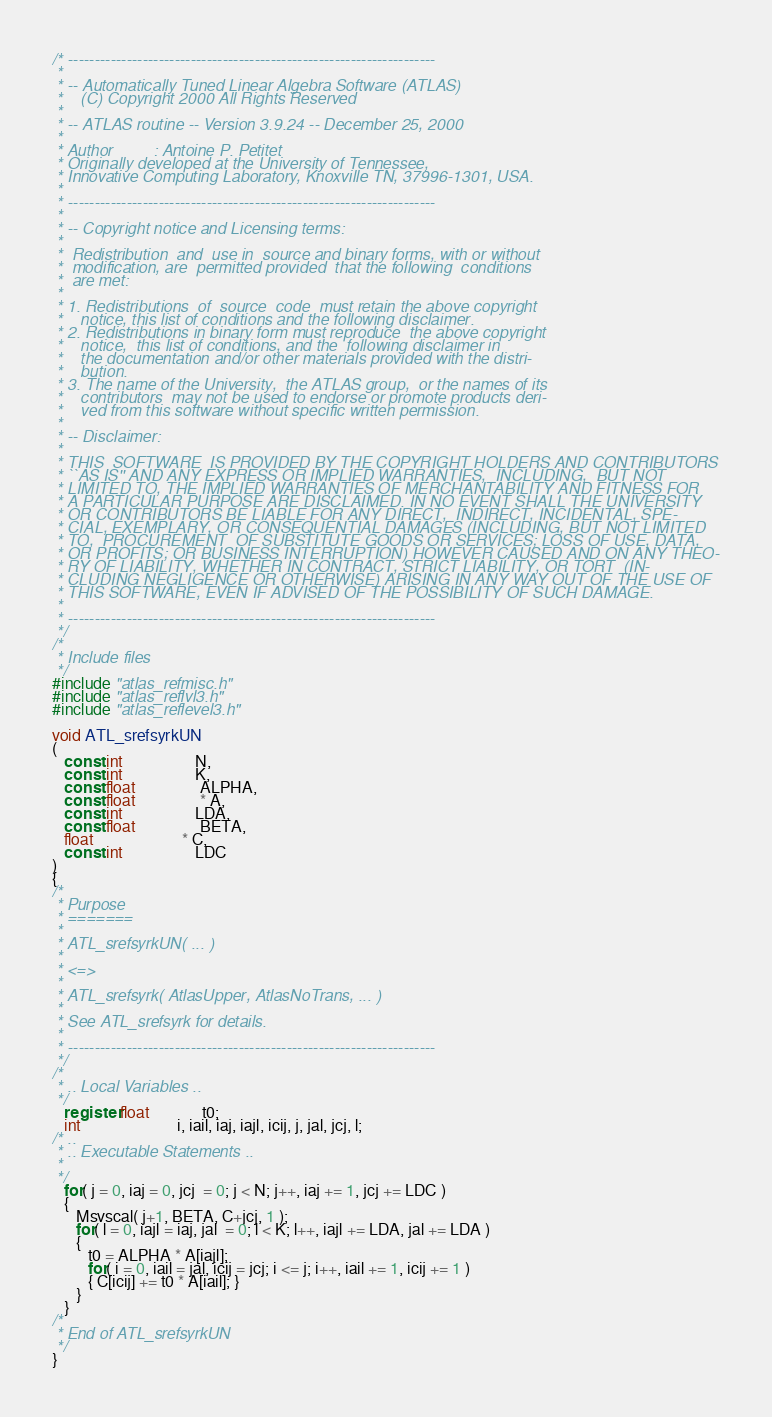Convert code to text. <code><loc_0><loc_0><loc_500><loc_500><_C_>/* ---------------------------------------------------------------------
 *
 * -- Automatically Tuned Linear Algebra Software (ATLAS)
 *    (C) Copyright 2000 All Rights Reserved
 *
 * -- ATLAS routine -- Version 3.9.24 -- December 25, 2000
 *
 * Author         : Antoine P. Petitet
 * Originally developed at the University of Tennessee,
 * Innovative Computing Laboratory, Knoxville TN, 37996-1301, USA.
 *
 * ---------------------------------------------------------------------
 *
 * -- Copyright notice and Licensing terms:
 *
 *  Redistribution  and  use in  source and binary forms, with or without
 *  modification, are  permitted provided  that the following  conditions
 *  are met:
 *
 * 1. Redistributions  of  source  code  must retain the above copyright
 *    notice, this list of conditions and the following disclaimer.
 * 2. Redistributions in binary form must reproduce  the above copyright
 *    notice,  this list of conditions, and the  following disclaimer in
 *    the documentation and/or other materials provided with the distri-
 *    bution.
 * 3. The name of the University,  the ATLAS group,  or the names of its
 *    contributors  may not be used to endorse or promote products deri-
 *    ved from this software without specific written permission.
 *
 * -- Disclaimer:
 *
 * THIS  SOFTWARE  IS PROVIDED BY THE COPYRIGHT HOLDERS AND CONTRIBUTORS
 * ``AS IS'' AND ANY EXPRESS OR IMPLIED WARRANTIES,  INCLUDING,  BUT NOT
 * LIMITED TO, THE IMPLIED WARRANTIES OF MERCHANTABILITY AND FITNESS FOR
 * A PARTICULAR PURPOSE ARE DISCLAIMED. IN NO EVENT SHALL THE UNIVERSITY
 * OR CONTRIBUTORS BE LIABLE FOR ANY DIRECT,  INDIRECT, INCIDENTAL, SPE-
 * CIAL, EXEMPLARY, OR CONSEQUENTIAL DAMAGES (INCLUDING, BUT NOT LIMITED
 * TO,  PROCUREMENT  OF SUBSTITUTE GOODS OR SERVICES; LOSS OF USE, DATA,
 * OR PROFITS; OR BUSINESS INTERRUPTION) HOWEVER CAUSED AND ON ANY THEO-
 * RY OF LIABILITY, WHETHER IN CONTRACT, STRICT LIABILITY, OR TORT  (IN-
 * CLUDING NEGLIGENCE OR OTHERWISE) ARISING IN ANY WAY OUT OF THE USE OF
 * THIS SOFTWARE, EVEN IF ADVISED OF THE POSSIBILITY OF SUCH DAMAGE.
 *
 * ---------------------------------------------------------------------
 */
/*
 * Include files
 */
#include "atlas_refmisc.h"
#include "atlas_reflvl3.h"
#include "atlas_reflevel3.h"

void ATL_srefsyrkUN
(
   const int                  N,
   const int                  K,
   const float                ALPHA,
   const float                * A,
   const int                  LDA,
   const float                BETA,
   float                      * C,
   const int                  LDC
)
{
/*
 * Purpose
 * =======
 *
 * ATL_srefsyrkUN( ... )
 *
 * <=>
 *
 * ATL_srefsyrk( AtlasUpper, AtlasNoTrans, ... )
 *
 * See ATL_srefsyrk for details.
 *
 * ---------------------------------------------------------------------
 */
/*
 * .. Local Variables ..
 */
   register float             t0;
   int                        i, iail, iaj, iajl, icij, j, jal, jcj, l;
/* ..
 * .. Executable Statements ..
 *
 */
   for( j = 0, iaj = 0, jcj  = 0; j < N; j++, iaj += 1, jcj += LDC )
   {
      Msvscal( j+1, BETA, C+jcj, 1 );
      for( l = 0, iajl = iaj, jal  = 0; l < K; l++, iajl += LDA, jal += LDA )
      {
         t0 = ALPHA * A[iajl];
         for( i = 0, iail = jal, icij = jcj; i <= j; i++, iail += 1, icij += 1 )
         { C[icij] += t0 * A[iail]; }
      }
   }
/*
 * End of ATL_srefsyrkUN
 */
}
</code> 